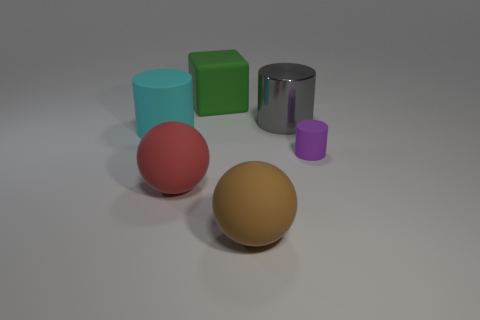Add 3 shiny spheres. How many objects exist? 9 Subtract all cubes. How many objects are left? 5 Add 5 big brown balls. How many big brown balls are left? 6 Add 2 cyan matte objects. How many cyan matte objects exist? 3 Subtract 0 green cylinders. How many objects are left? 6 Subtract all purple things. Subtract all green rubber things. How many objects are left? 4 